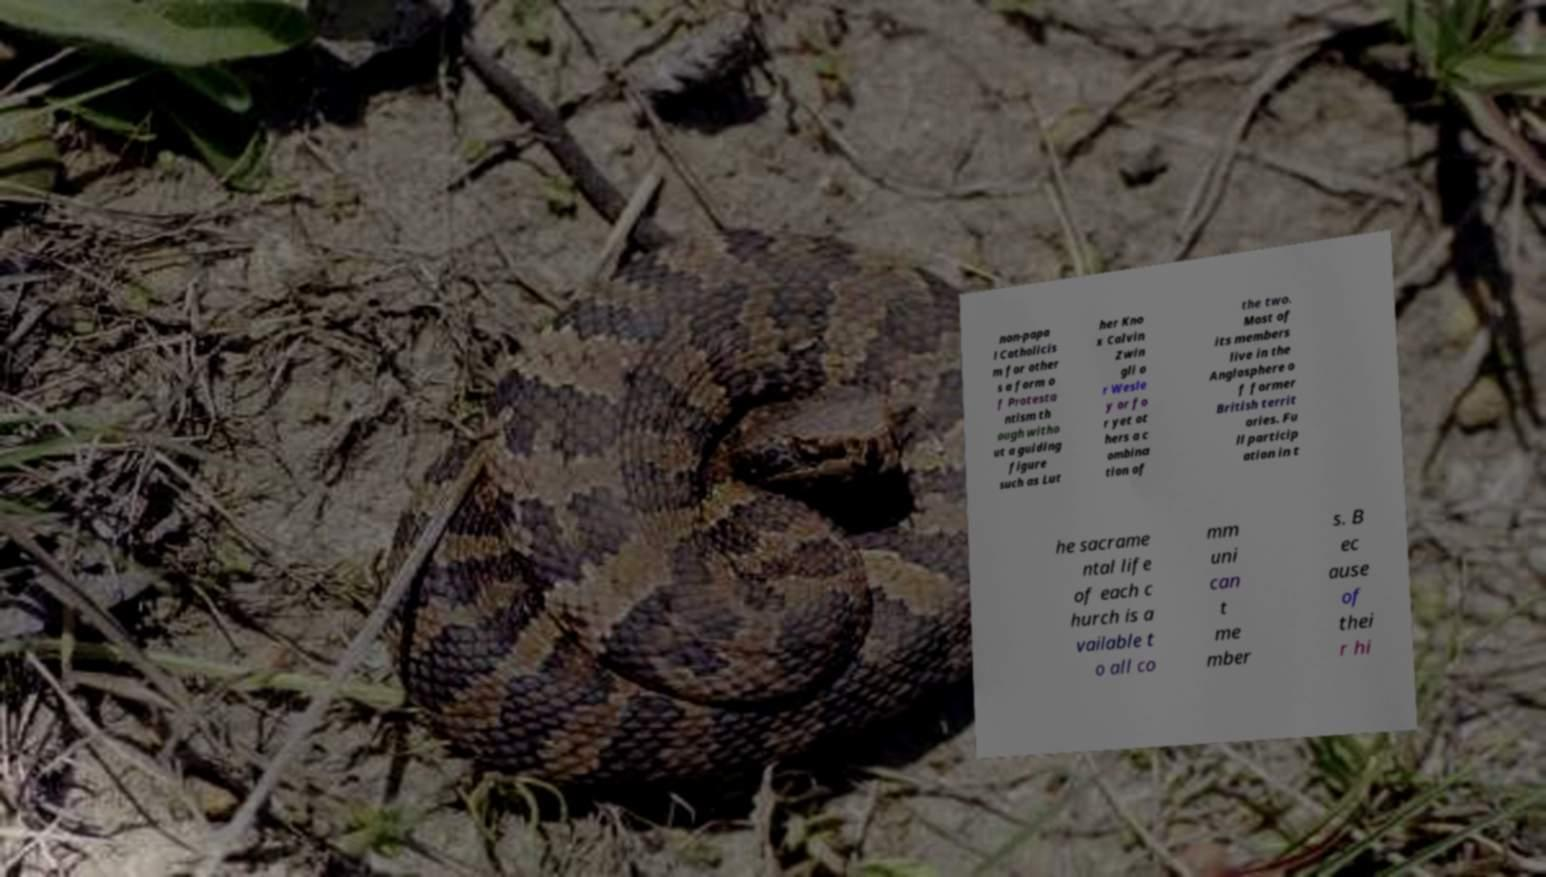Please identify and transcribe the text found in this image. non-papa l Catholicis m for other s a form o f Protesta ntism th ough witho ut a guiding figure such as Lut her Kno x Calvin Zwin gli o r Wesle y or fo r yet ot hers a c ombina tion of the two. Most of its members live in the Anglosphere o f former British territ ories. Fu ll particip ation in t he sacrame ntal life of each c hurch is a vailable t o all co mm uni can t me mber s. B ec ause of thei r hi 